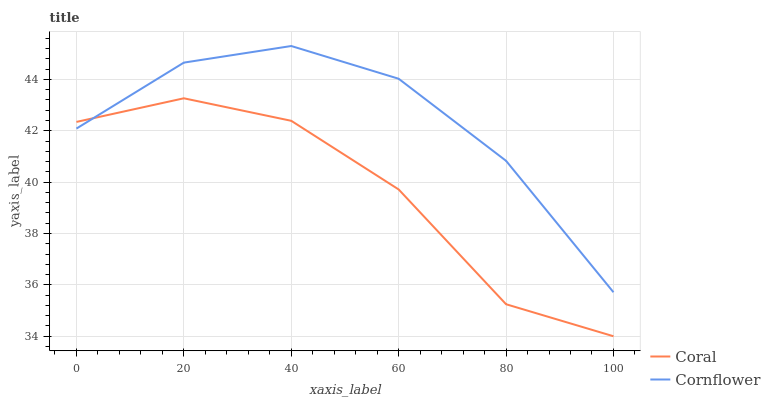Does Coral have the maximum area under the curve?
Answer yes or no. No. Is Coral the smoothest?
Answer yes or no. No. Does Coral have the highest value?
Answer yes or no. No. 